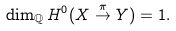<formula> <loc_0><loc_0><loc_500><loc_500>\dim _ { \mathbb { Q } } H ^ { 0 } ( X \stackrel { \pi } \to Y ) = 1 .</formula> 